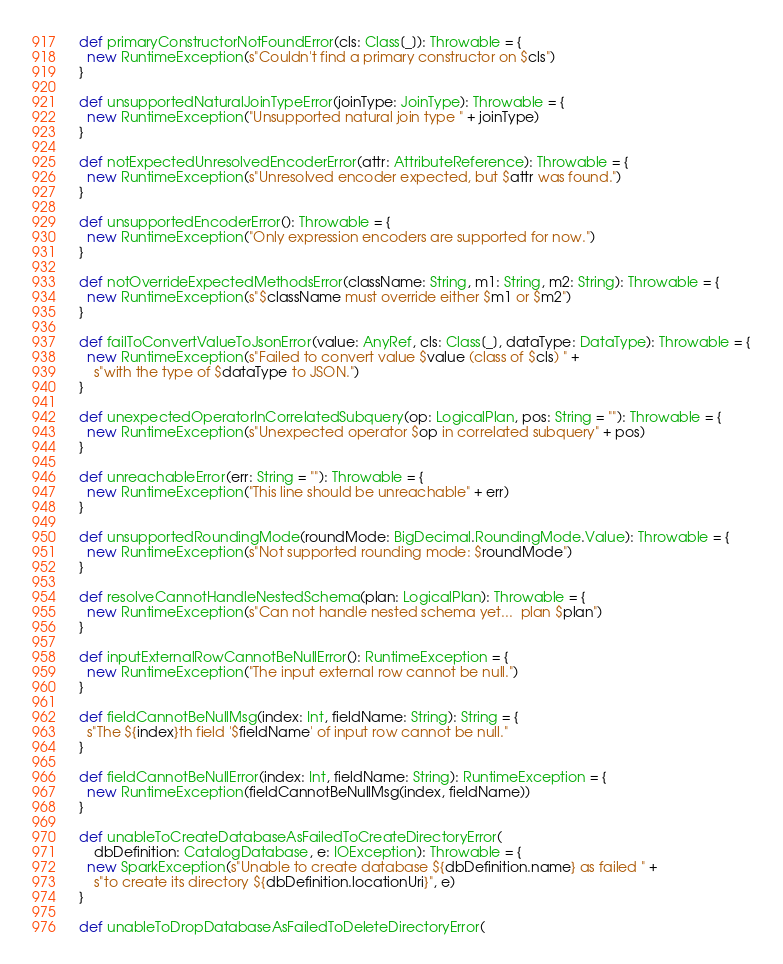<code> <loc_0><loc_0><loc_500><loc_500><_Scala_>  def primaryConstructorNotFoundError(cls: Class[_]): Throwable = {
    new RuntimeException(s"Couldn't find a primary constructor on $cls")
  }

  def unsupportedNaturalJoinTypeError(joinType: JoinType): Throwable = {
    new RuntimeException("Unsupported natural join type " + joinType)
  }

  def notExpectedUnresolvedEncoderError(attr: AttributeReference): Throwable = {
    new RuntimeException(s"Unresolved encoder expected, but $attr was found.")
  }

  def unsupportedEncoderError(): Throwable = {
    new RuntimeException("Only expression encoders are supported for now.")
  }

  def notOverrideExpectedMethodsError(className: String, m1: String, m2: String): Throwable = {
    new RuntimeException(s"$className must override either $m1 or $m2")
  }

  def failToConvertValueToJsonError(value: AnyRef, cls: Class[_], dataType: DataType): Throwable = {
    new RuntimeException(s"Failed to convert value $value (class of $cls) " +
      s"with the type of $dataType to JSON.")
  }

  def unexpectedOperatorInCorrelatedSubquery(op: LogicalPlan, pos: String = ""): Throwable = {
    new RuntimeException(s"Unexpected operator $op in correlated subquery" + pos)
  }

  def unreachableError(err: String = ""): Throwable = {
    new RuntimeException("This line should be unreachable" + err)
  }

  def unsupportedRoundingMode(roundMode: BigDecimal.RoundingMode.Value): Throwable = {
    new RuntimeException(s"Not supported rounding mode: $roundMode")
  }

  def resolveCannotHandleNestedSchema(plan: LogicalPlan): Throwable = {
    new RuntimeException(s"Can not handle nested schema yet...  plan $plan")
  }

  def inputExternalRowCannotBeNullError(): RuntimeException = {
    new RuntimeException("The input external row cannot be null.")
  }

  def fieldCannotBeNullMsg(index: Int, fieldName: String): String = {
    s"The ${index}th field '$fieldName' of input row cannot be null."
  }

  def fieldCannotBeNullError(index: Int, fieldName: String): RuntimeException = {
    new RuntimeException(fieldCannotBeNullMsg(index, fieldName))
  }

  def unableToCreateDatabaseAsFailedToCreateDirectoryError(
      dbDefinition: CatalogDatabase, e: IOException): Throwable = {
    new SparkException(s"Unable to create database ${dbDefinition.name} as failed " +
      s"to create its directory ${dbDefinition.locationUri}", e)
  }

  def unableToDropDatabaseAsFailedToDeleteDirectoryError(</code> 